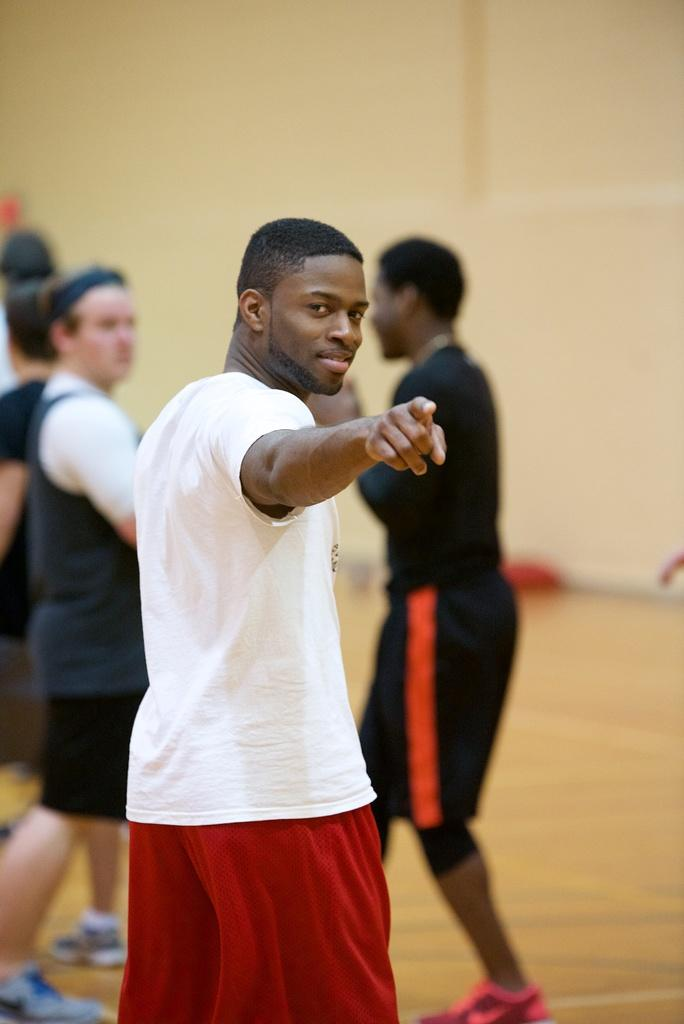Where was the image taken? The image was taken indoors. What can be seen in the image? There is a group of persons in the image. What is the position of the persons in the image? The persons are standing on the floor. What is visible in the background of the image? There is a wall and other objects visible in the background of the image. Can you see any wires hanging from the ceiling in the image? There is no mention of wires hanging from the ceiling in the provided facts, so we cannot determine their presence in the image. Is there a toad hopping on the floor in the image? There is no mention of a toad in the provided facts, so we cannot determine its presence in the image. 